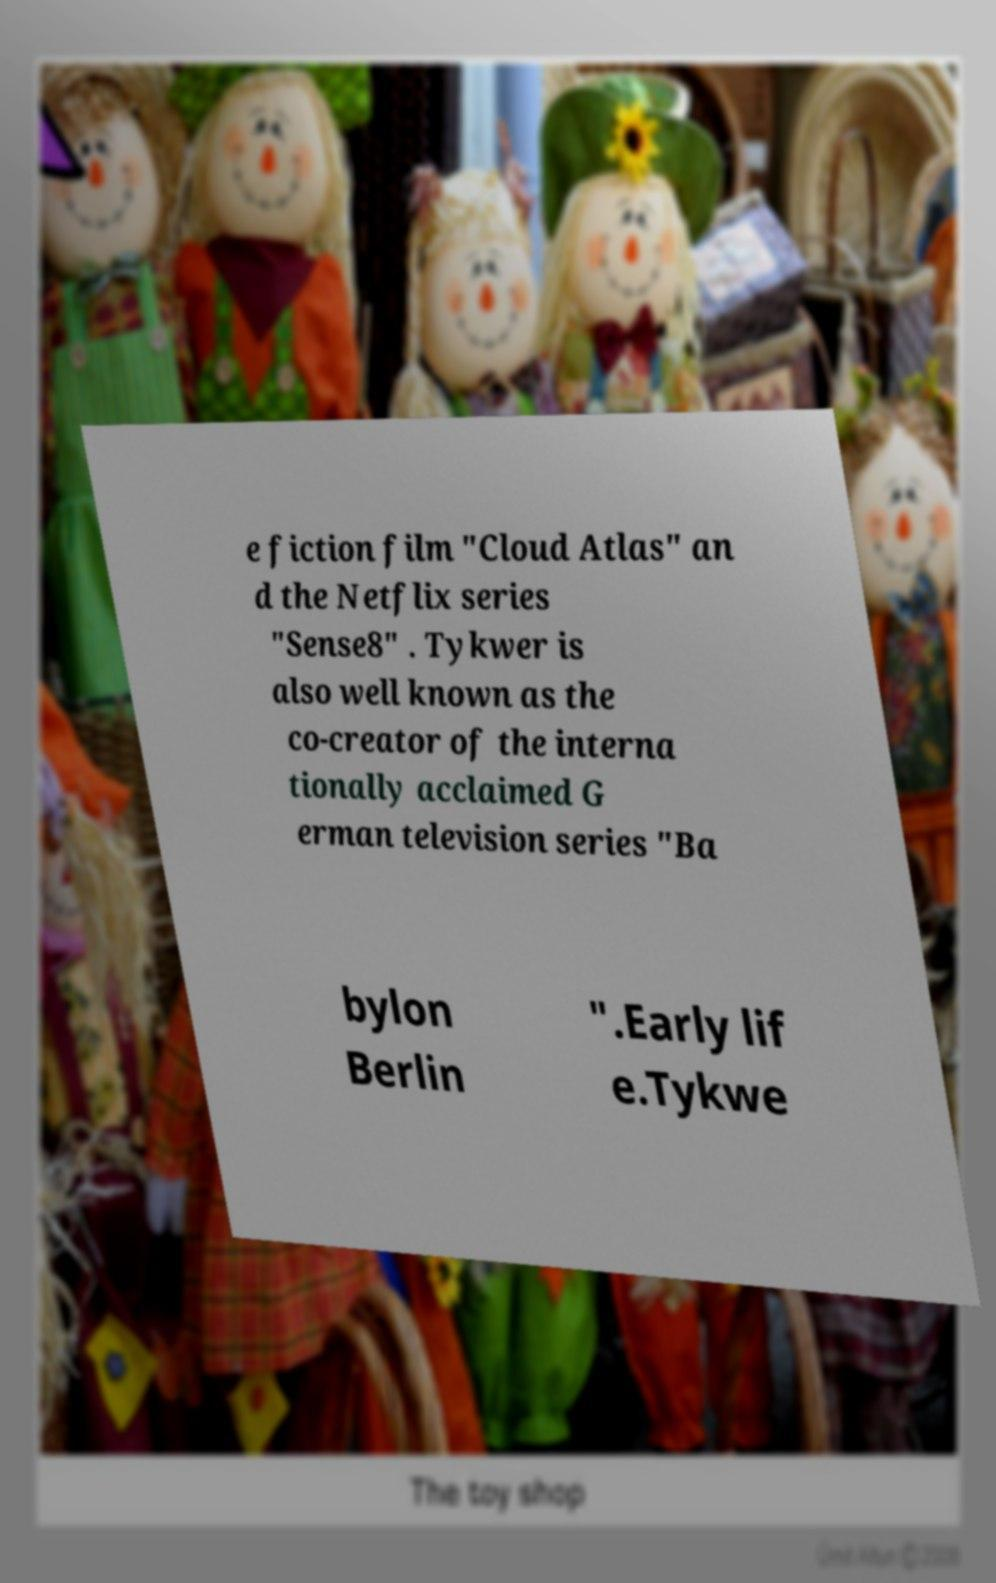Please identify and transcribe the text found in this image. e fiction film "Cloud Atlas" an d the Netflix series "Sense8" . Tykwer is also well known as the co-creator of the interna tionally acclaimed G erman television series "Ba bylon Berlin ".Early lif e.Tykwe 